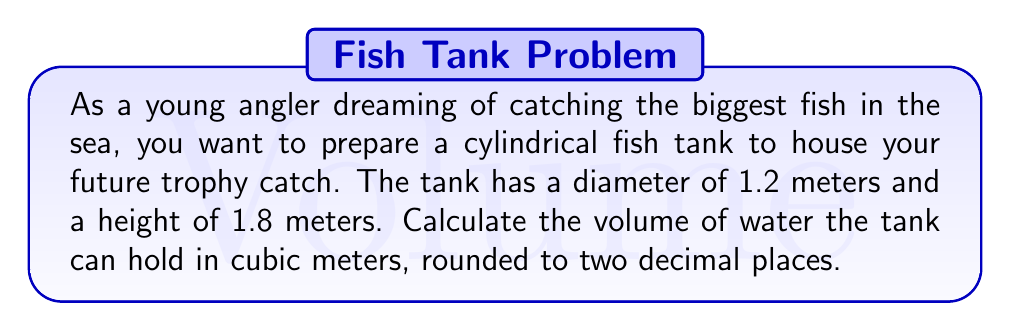What is the answer to this math problem? To calculate the volume of a cylindrical fish tank, we need to use the formula for the volume of a cylinder:

$$V = \pi r^2 h$$

Where:
$V$ = volume
$\pi$ = pi (approximately 3.14159)
$r$ = radius of the base
$h$ = height of the cylinder

Given:
- Diameter = 1.2 meters
- Height = 1.8 meters

Step 1: Calculate the radius
The radius is half the diameter:
$r = \frac{1.2}{2} = 0.6$ meters

Step 2: Apply the volume formula
$$V = \pi (0.6\text{ m})^2 (1.8\text{ m})$$

Step 3: Calculate the result
$$\begin{align*}
V &= \pi (0.36\text{ m}^2) (1.8\text{ m}) \\
&= 3.14159 \times 0.36 \times 1.8 \\
&= 2.0362\ldots \text{ m}^3
\end{align*}$$

Step 4: Round to two decimal places
$V \approx 2.04\text{ m}^3$

[asy]
import geometry;

size(200);
real r = 30;
real h = 50;

path base = circle((0,0), r);
path top = circle((0,h), r);

draw(base);
draw(top);
draw((r,0)--(r,h));
draw((-r,0)--(-r,h));

label("1.2 m", (r,h/2), E);
label("1.8 m", (0,h/2), W);

draw((0,0)--(r,0), arrow=Arrow(TeXHead));
label("0.6 m", (r/2,0), S);
[/asy]
Answer: The volume of the cylindrical fish tank is approximately $2.04\text{ m}^3$. 